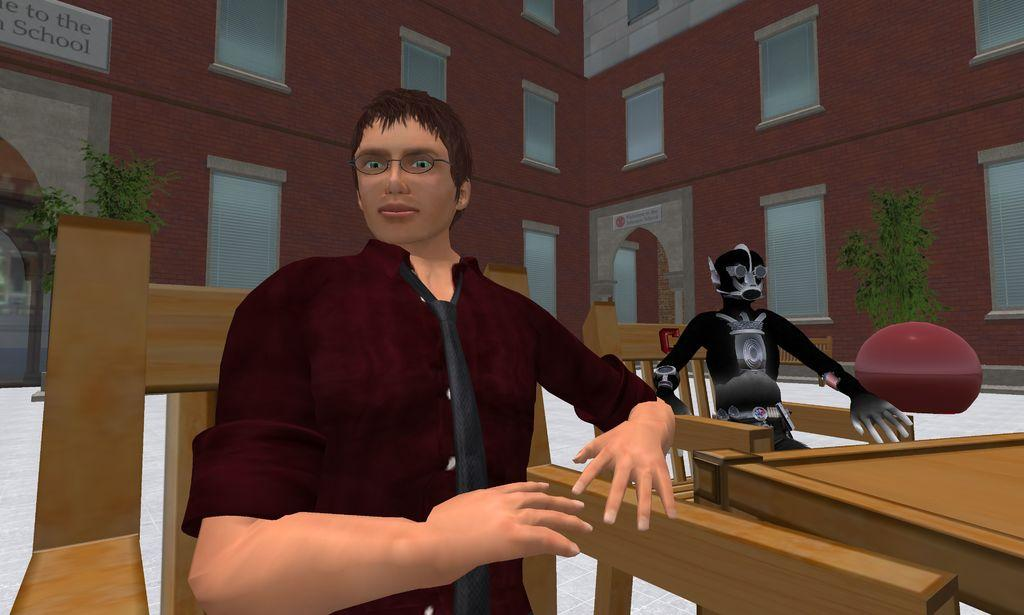What is the person in the image doing? The person is sitting in a chair. Where is the person sitting in relation to the table? The person is beside a table. What else is placed in a chair in the image? There is a robot placed in a chair. What type of vegetation can be seen in the image? There are plants visible in the image. What type of structure is visible in the background? There is a building with windows in the image. What is on the building? There is a signboard on the building. What type of rhythm does the tin have in the image? There is no tin present in the image, so it is not possible to determine its rhythm. 